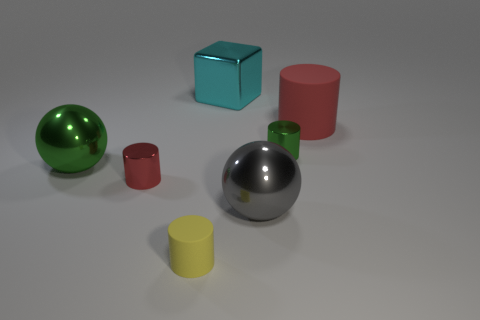What shape is the small metallic thing on the right side of the big cyan object?
Provide a succinct answer. Cylinder. There is a rubber object behind the big gray shiny object; is it the same shape as the thing that is in front of the gray ball?
Offer a very short reply. Yes. Are there an equal number of gray metal balls that are behind the big cyan block and rubber objects?
Ensure brevity in your answer.  No. Are there any other things that are the same size as the gray shiny sphere?
Give a very brief answer. Yes. There is a green object that is the same shape as the gray metal object; what is it made of?
Your response must be concise. Metal. There is a tiny shiny thing behind the green object left of the small red shiny cylinder; what is its shape?
Offer a very short reply. Cylinder. Does the green thing that is to the left of the large metallic cube have the same material as the large cylinder?
Ensure brevity in your answer.  No. Is the number of large gray shiny objects behind the small red cylinder the same as the number of green metallic spheres right of the tiny yellow rubber cylinder?
Offer a very short reply. Yes. There is a tiny cylinder that is the same color as the large rubber object; what is its material?
Keep it short and to the point. Metal. What number of metallic blocks are in front of the small cylinder that is behind the tiny red metal thing?
Your answer should be very brief. 0. 